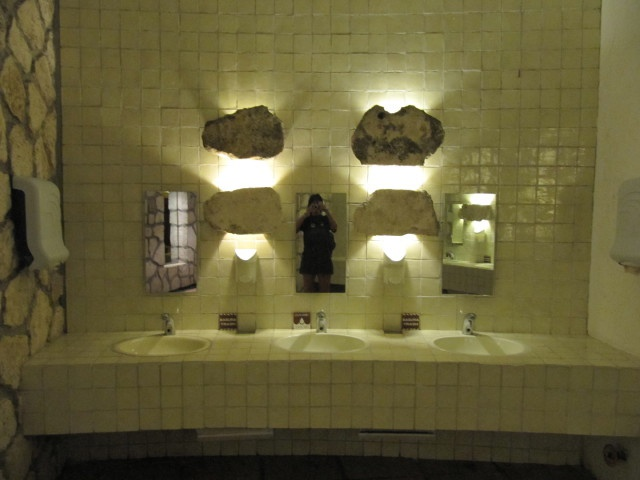Describe the objects in this image and their specific colors. I can see people in black, darkgreen, and gray tones, sink in black, olive, khaki, and tan tones, sink in black and olive tones, sink in black and olive tones, and handbag in black tones in this image. 